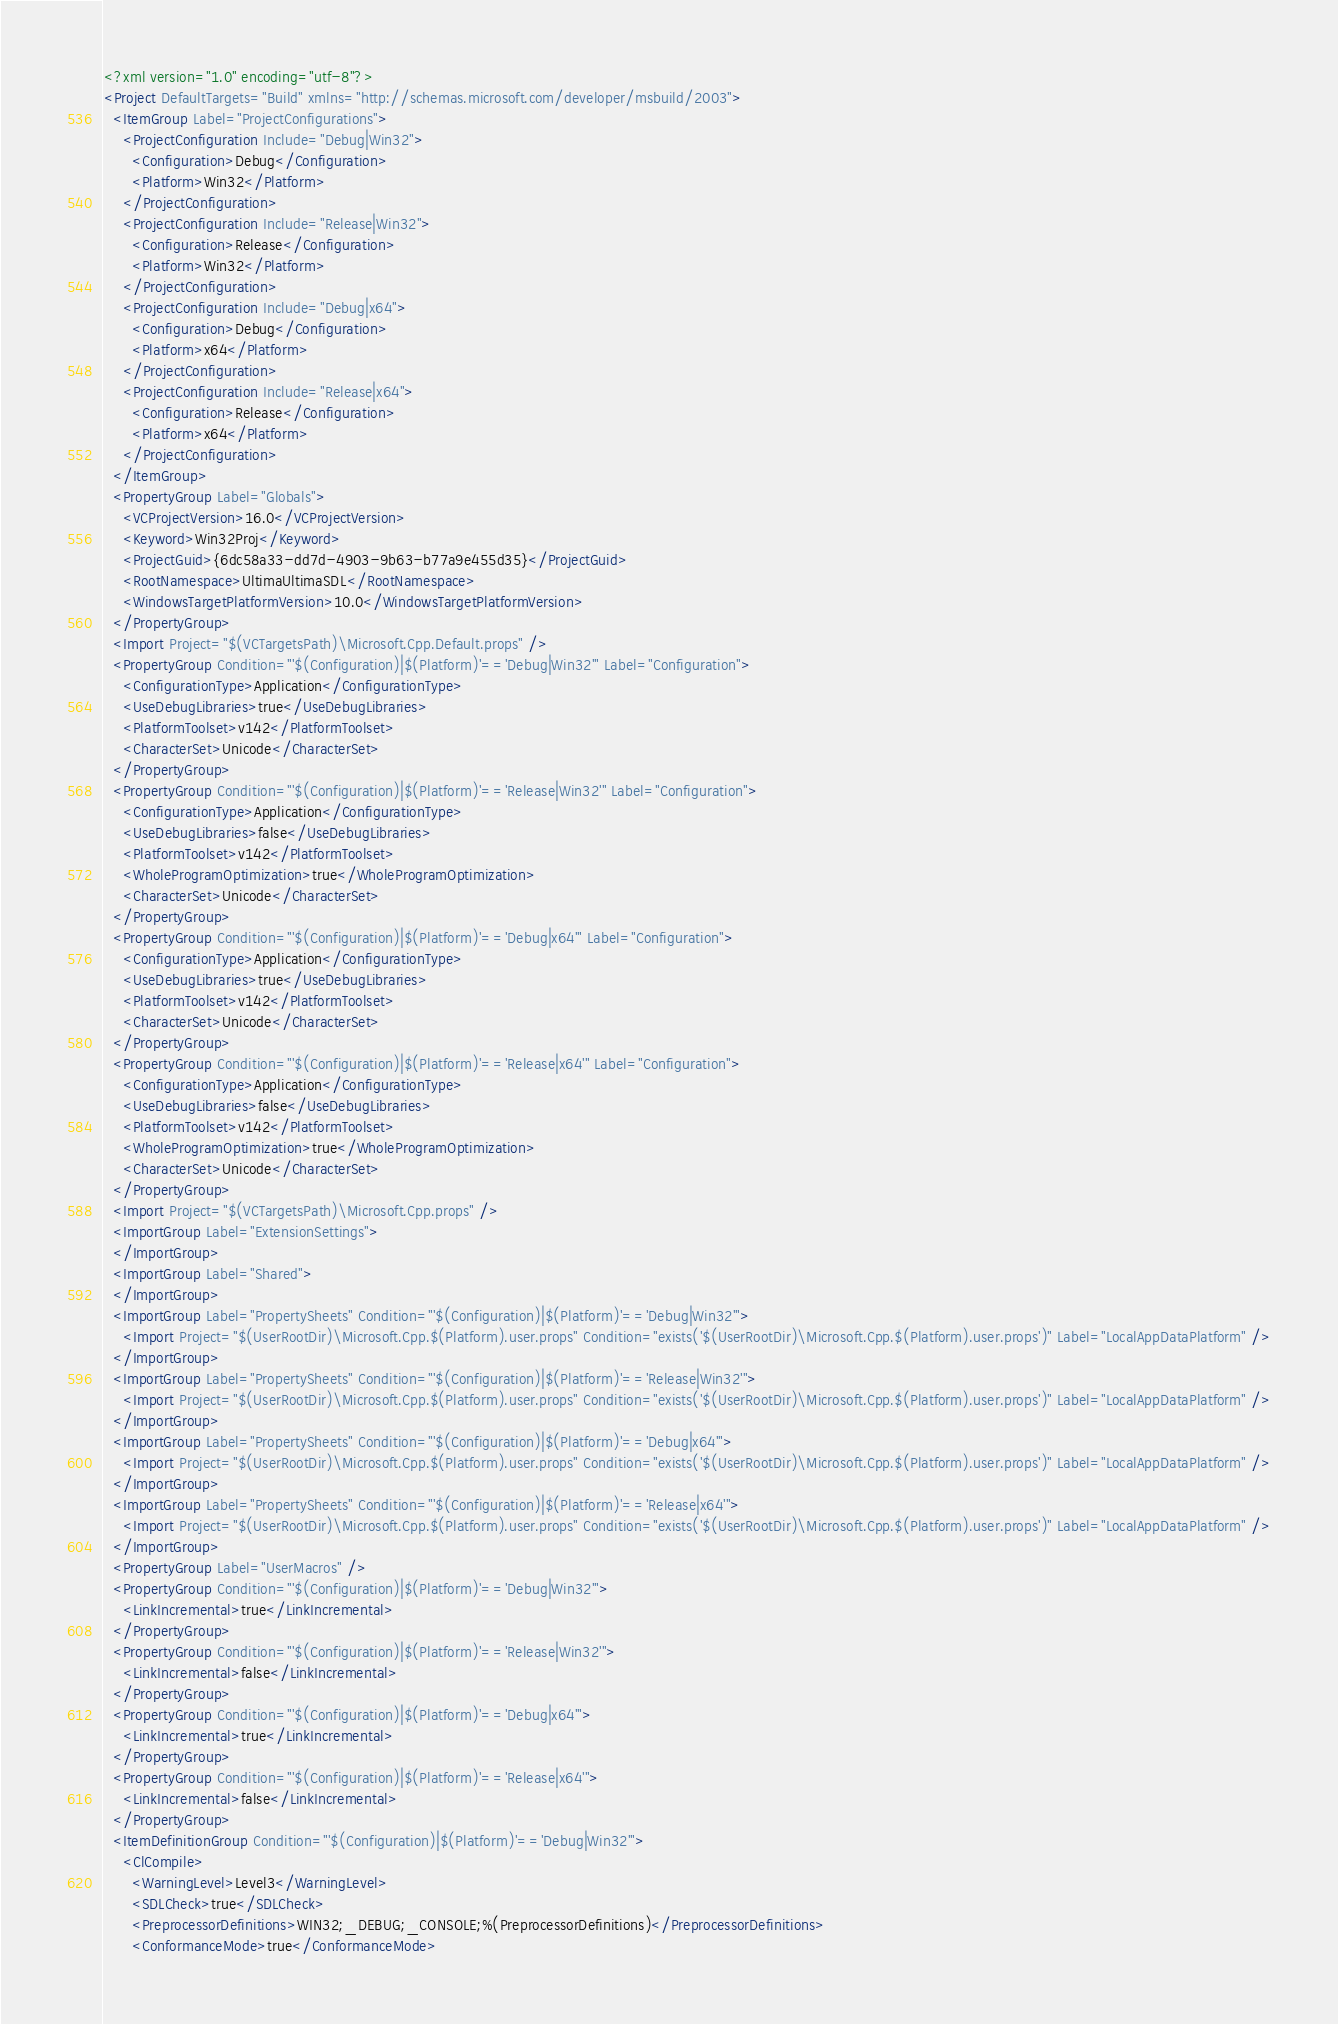Convert code to text. <code><loc_0><loc_0><loc_500><loc_500><_XML_><?xml version="1.0" encoding="utf-8"?>
<Project DefaultTargets="Build" xmlns="http://schemas.microsoft.com/developer/msbuild/2003">
  <ItemGroup Label="ProjectConfigurations">
    <ProjectConfiguration Include="Debug|Win32">
      <Configuration>Debug</Configuration>
      <Platform>Win32</Platform>
    </ProjectConfiguration>
    <ProjectConfiguration Include="Release|Win32">
      <Configuration>Release</Configuration>
      <Platform>Win32</Platform>
    </ProjectConfiguration>
    <ProjectConfiguration Include="Debug|x64">
      <Configuration>Debug</Configuration>
      <Platform>x64</Platform>
    </ProjectConfiguration>
    <ProjectConfiguration Include="Release|x64">
      <Configuration>Release</Configuration>
      <Platform>x64</Platform>
    </ProjectConfiguration>
  </ItemGroup>
  <PropertyGroup Label="Globals">
    <VCProjectVersion>16.0</VCProjectVersion>
    <Keyword>Win32Proj</Keyword>
    <ProjectGuid>{6dc58a33-dd7d-4903-9b63-b77a9e455d35}</ProjectGuid>
    <RootNamespace>UltimaUltimaSDL</RootNamespace>
    <WindowsTargetPlatformVersion>10.0</WindowsTargetPlatformVersion>
  </PropertyGroup>
  <Import Project="$(VCTargetsPath)\Microsoft.Cpp.Default.props" />
  <PropertyGroup Condition="'$(Configuration)|$(Platform)'=='Debug|Win32'" Label="Configuration">
    <ConfigurationType>Application</ConfigurationType>
    <UseDebugLibraries>true</UseDebugLibraries>
    <PlatformToolset>v142</PlatformToolset>
    <CharacterSet>Unicode</CharacterSet>
  </PropertyGroup>
  <PropertyGroup Condition="'$(Configuration)|$(Platform)'=='Release|Win32'" Label="Configuration">
    <ConfigurationType>Application</ConfigurationType>
    <UseDebugLibraries>false</UseDebugLibraries>
    <PlatformToolset>v142</PlatformToolset>
    <WholeProgramOptimization>true</WholeProgramOptimization>
    <CharacterSet>Unicode</CharacterSet>
  </PropertyGroup>
  <PropertyGroup Condition="'$(Configuration)|$(Platform)'=='Debug|x64'" Label="Configuration">
    <ConfigurationType>Application</ConfigurationType>
    <UseDebugLibraries>true</UseDebugLibraries>
    <PlatformToolset>v142</PlatformToolset>
    <CharacterSet>Unicode</CharacterSet>
  </PropertyGroup>
  <PropertyGroup Condition="'$(Configuration)|$(Platform)'=='Release|x64'" Label="Configuration">
    <ConfigurationType>Application</ConfigurationType>
    <UseDebugLibraries>false</UseDebugLibraries>
    <PlatformToolset>v142</PlatformToolset>
    <WholeProgramOptimization>true</WholeProgramOptimization>
    <CharacterSet>Unicode</CharacterSet>
  </PropertyGroup>
  <Import Project="$(VCTargetsPath)\Microsoft.Cpp.props" />
  <ImportGroup Label="ExtensionSettings">
  </ImportGroup>
  <ImportGroup Label="Shared">
  </ImportGroup>
  <ImportGroup Label="PropertySheets" Condition="'$(Configuration)|$(Platform)'=='Debug|Win32'">
    <Import Project="$(UserRootDir)\Microsoft.Cpp.$(Platform).user.props" Condition="exists('$(UserRootDir)\Microsoft.Cpp.$(Platform).user.props')" Label="LocalAppDataPlatform" />
  </ImportGroup>
  <ImportGroup Label="PropertySheets" Condition="'$(Configuration)|$(Platform)'=='Release|Win32'">
    <Import Project="$(UserRootDir)\Microsoft.Cpp.$(Platform).user.props" Condition="exists('$(UserRootDir)\Microsoft.Cpp.$(Platform).user.props')" Label="LocalAppDataPlatform" />
  </ImportGroup>
  <ImportGroup Label="PropertySheets" Condition="'$(Configuration)|$(Platform)'=='Debug|x64'">
    <Import Project="$(UserRootDir)\Microsoft.Cpp.$(Platform).user.props" Condition="exists('$(UserRootDir)\Microsoft.Cpp.$(Platform).user.props')" Label="LocalAppDataPlatform" />
  </ImportGroup>
  <ImportGroup Label="PropertySheets" Condition="'$(Configuration)|$(Platform)'=='Release|x64'">
    <Import Project="$(UserRootDir)\Microsoft.Cpp.$(Platform).user.props" Condition="exists('$(UserRootDir)\Microsoft.Cpp.$(Platform).user.props')" Label="LocalAppDataPlatform" />
  </ImportGroup>
  <PropertyGroup Label="UserMacros" />
  <PropertyGroup Condition="'$(Configuration)|$(Platform)'=='Debug|Win32'">
    <LinkIncremental>true</LinkIncremental>
  </PropertyGroup>
  <PropertyGroup Condition="'$(Configuration)|$(Platform)'=='Release|Win32'">
    <LinkIncremental>false</LinkIncremental>
  </PropertyGroup>
  <PropertyGroup Condition="'$(Configuration)|$(Platform)'=='Debug|x64'">
    <LinkIncremental>true</LinkIncremental>
  </PropertyGroup>
  <PropertyGroup Condition="'$(Configuration)|$(Platform)'=='Release|x64'">
    <LinkIncremental>false</LinkIncremental>
  </PropertyGroup>
  <ItemDefinitionGroup Condition="'$(Configuration)|$(Platform)'=='Debug|Win32'">
    <ClCompile>
      <WarningLevel>Level3</WarningLevel>
      <SDLCheck>true</SDLCheck>
      <PreprocessorDefinitions>WIN32;_DEBUG;_CONSOLE;%(PreprocessorDefinitions)</PreprocessorDefinitions>
      <ConformanceMode>true</ConformanceMode></code> 